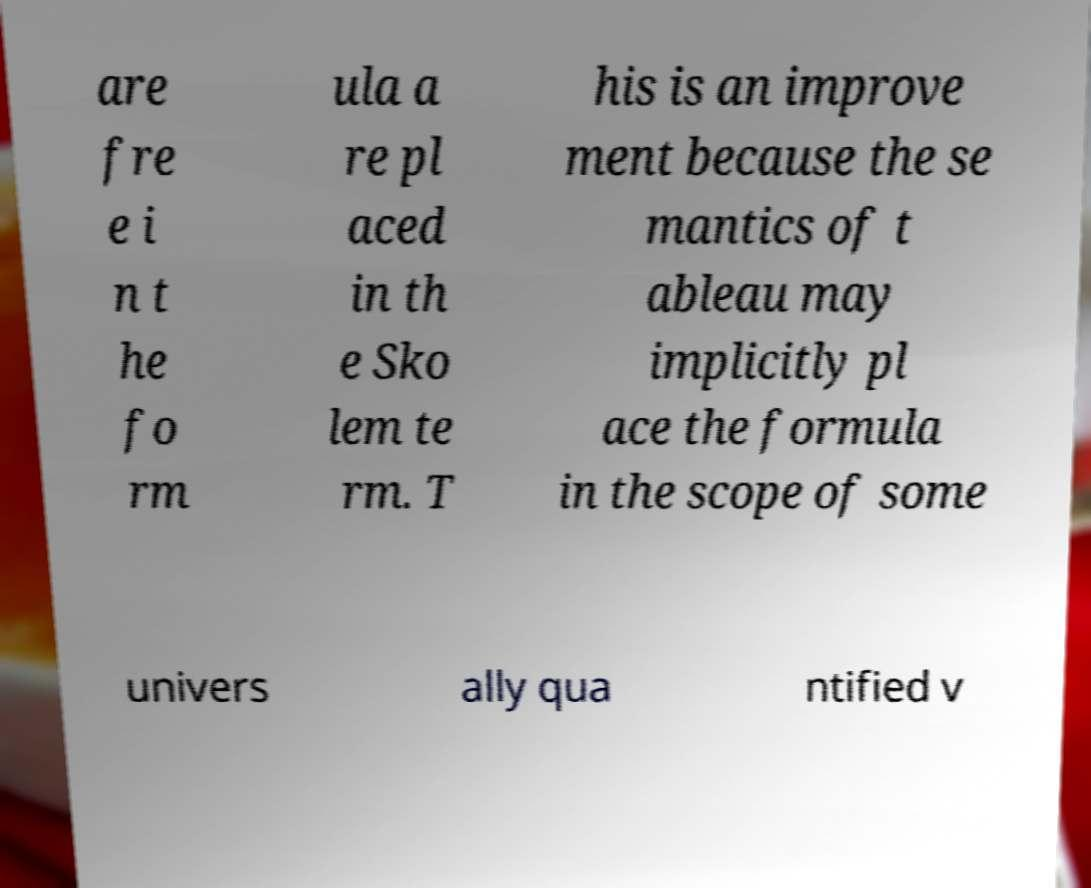What messages or text are displayed in this image? I need them in a readable, typed format. are fre e i n t he fo rm ula a re pl aced in th e Sko lem te rm. T his is an improve ment because the se mantics of t ableau may implicitly pl ace the formula in the scope of some univers ally qua ntified v 